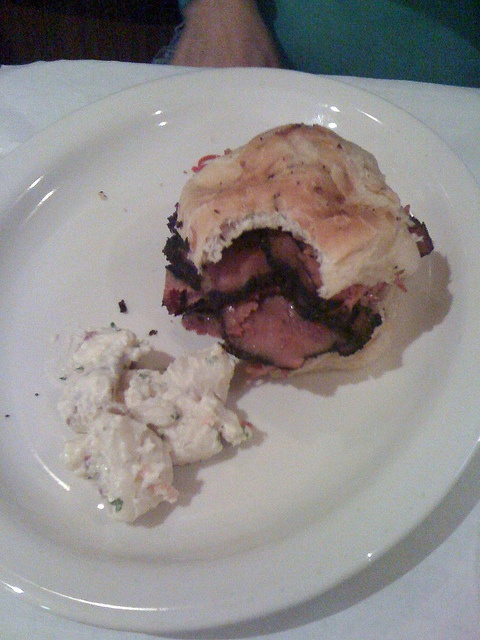Describe the objects in this image and their specific colors. I can see dining table in darkgray, black, and gray tones, sandwich in black and gray tones, cake in black, gray, and brown tones, cake in black, darkgray, and gray tones, and people in black, gray, and purple tones in this image. 